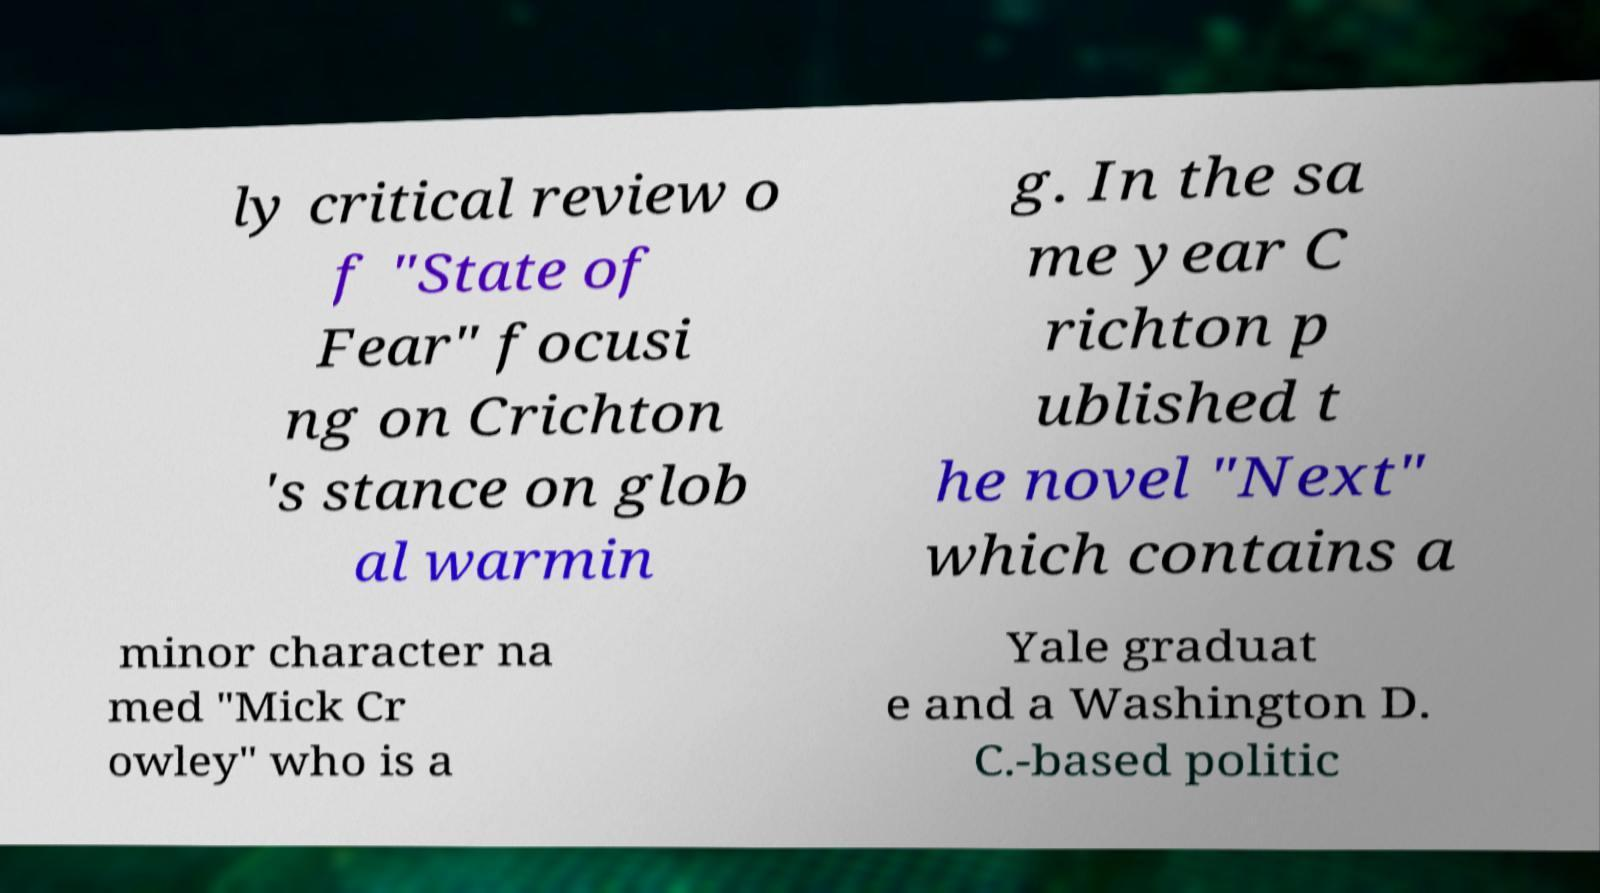For documentation purposes, I need the text within this image transcribed. Could you provide that? ly critical review o f "State of Fear" focusi ng on Crichton 's stance on glob al warmin g. In the sa me year C richton p ublished t he novel "Next" which contains a minor character na med "Mick Cr owley" who is a Yale graduat e and a Washington D. C.-based politic 